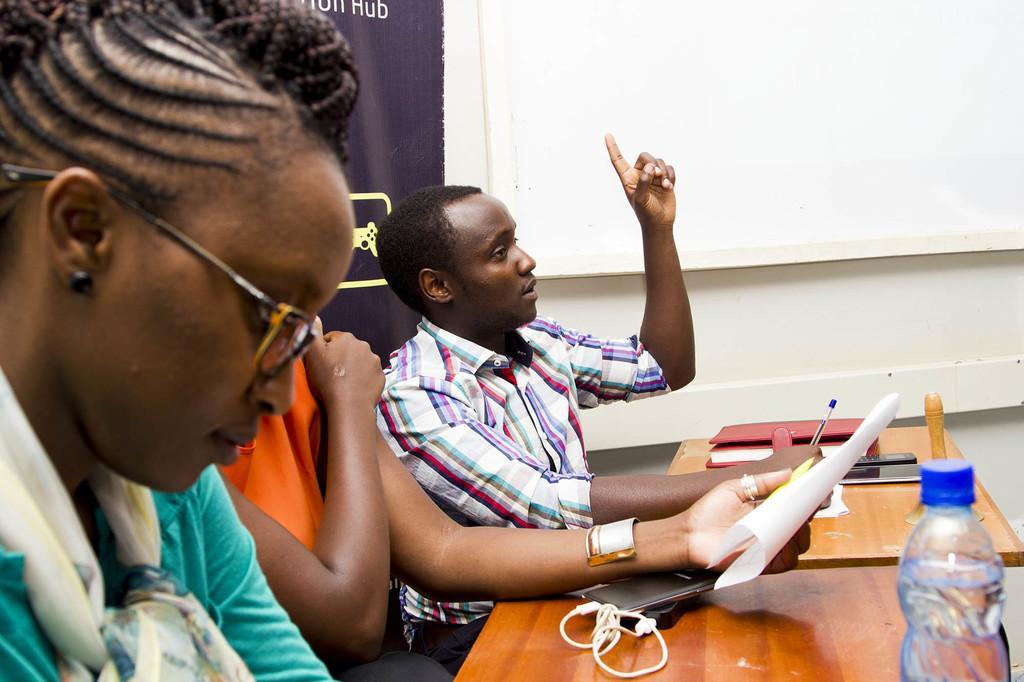How would you summarize this image in a sentence or two? In this image I see I can see 3 persons and all of them are sitting and I can also see that one of the person is holding a paper with hand. I can see that there are tables in front of them and there are few things on it. In the background I can see the wall and a banner. 